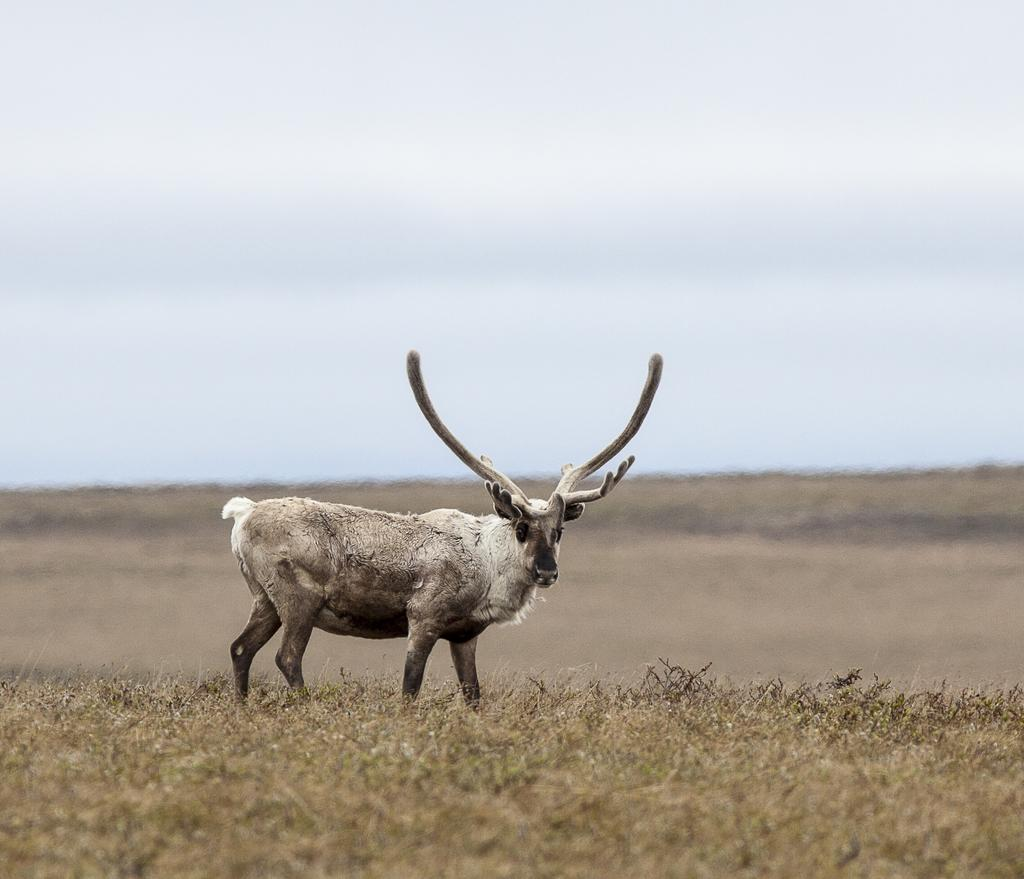What animal is in the foreground of the image? There is a deer in the foreground of the image. What is the deer standing on? The deer is on the grass. What can be seen in the background of the image? The background of the image includes the sky. Where might this image have been taken? The image is likely taken in a forest. When might this image have been taken? The image is likely taken during the day. What type of orange is being peeled in the image? There is no orange present in the image; it features a deer in a forest setting. 